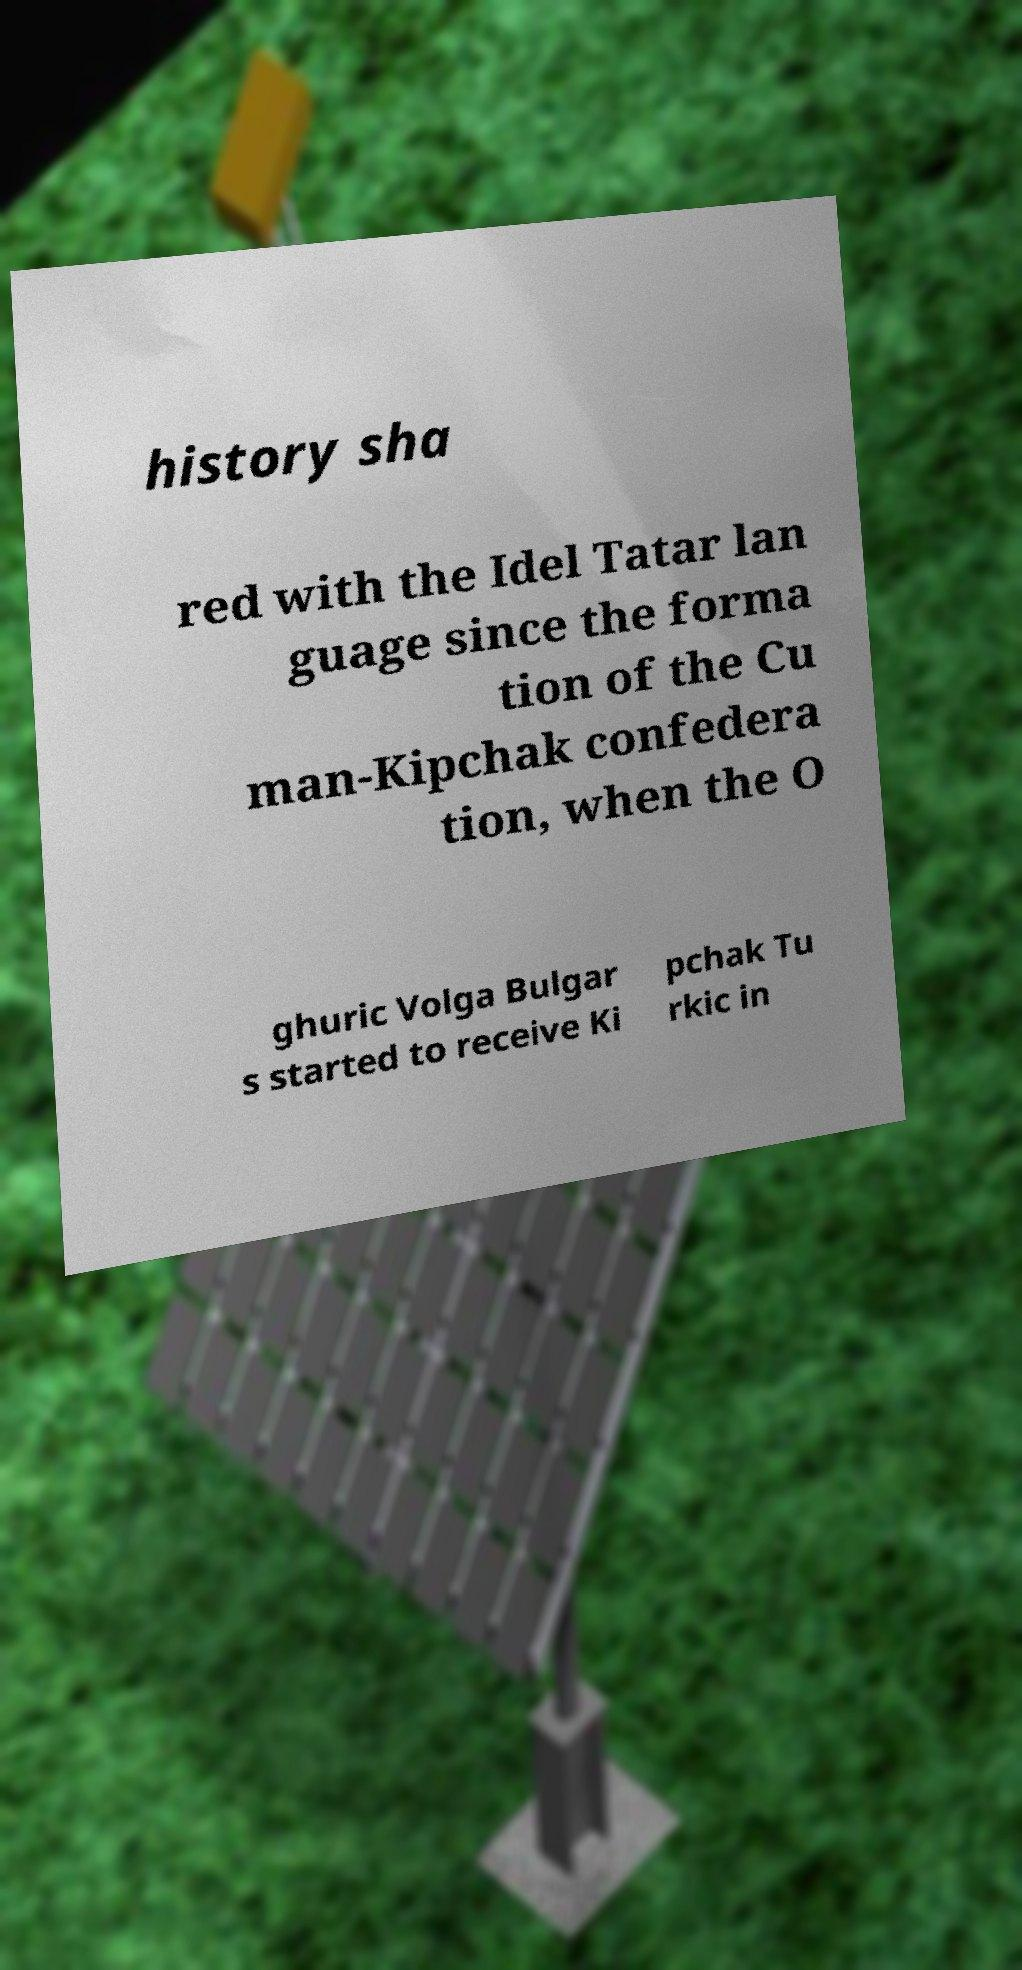What messages or text are displayed in this image? I need them in a readable, typed format. history sha red with the Idel Tatar lan guage since the forma tion of the Cu man-Kipchak confedera tion, when the O ghuric Volga Bulgar s started to receive Ki pchak Tu rkic in 